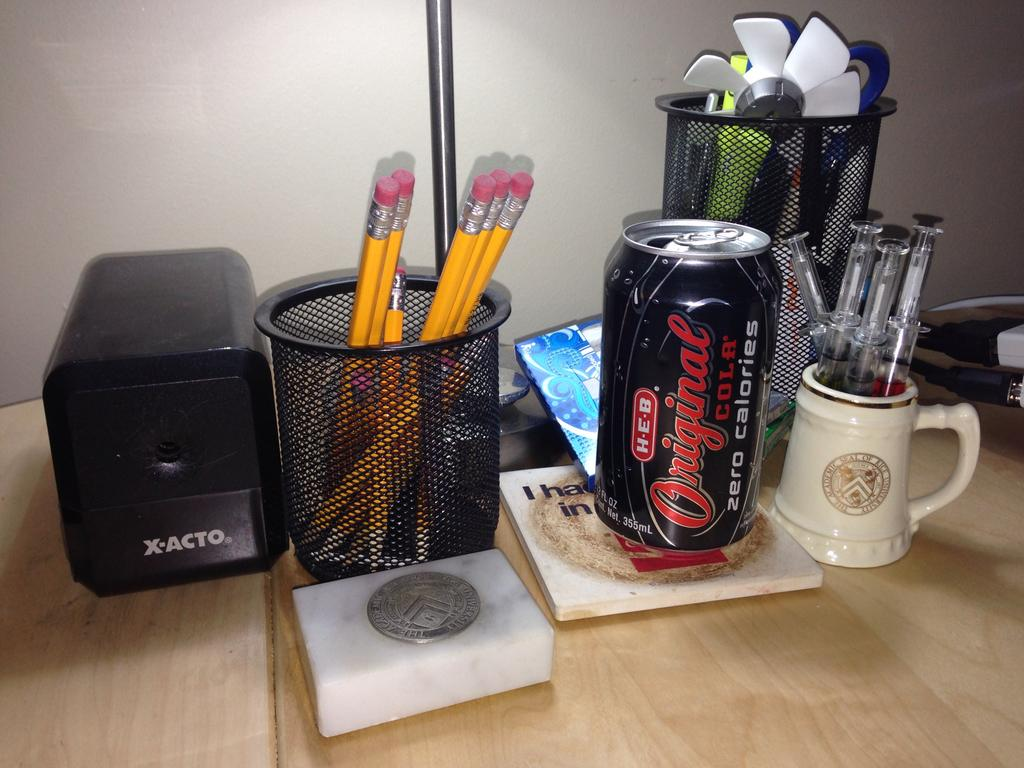<image>
Give a short and clear explanation of the subsequent image. an original soda on top of a table 